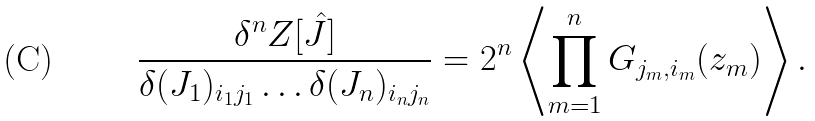Convert formula to latex. <formula><loc_0><loc_0><loc_500><loc_500>\frac { \delta ^ { n } Z [ \hat { J } ] } { \delta ( J _ { 1 } ) _ { i _ { 1 } j _ { 1 } } \dots \delta ( J _ { n } ) _ { i _ { n } j _ { n } } } = 2 ^ { n } \left \langle \prod _ { m = 1 } ^ { n } G _ { j _ { m } , i _ { m } } ( z _ { m } ) \right \rangle .</formula> 